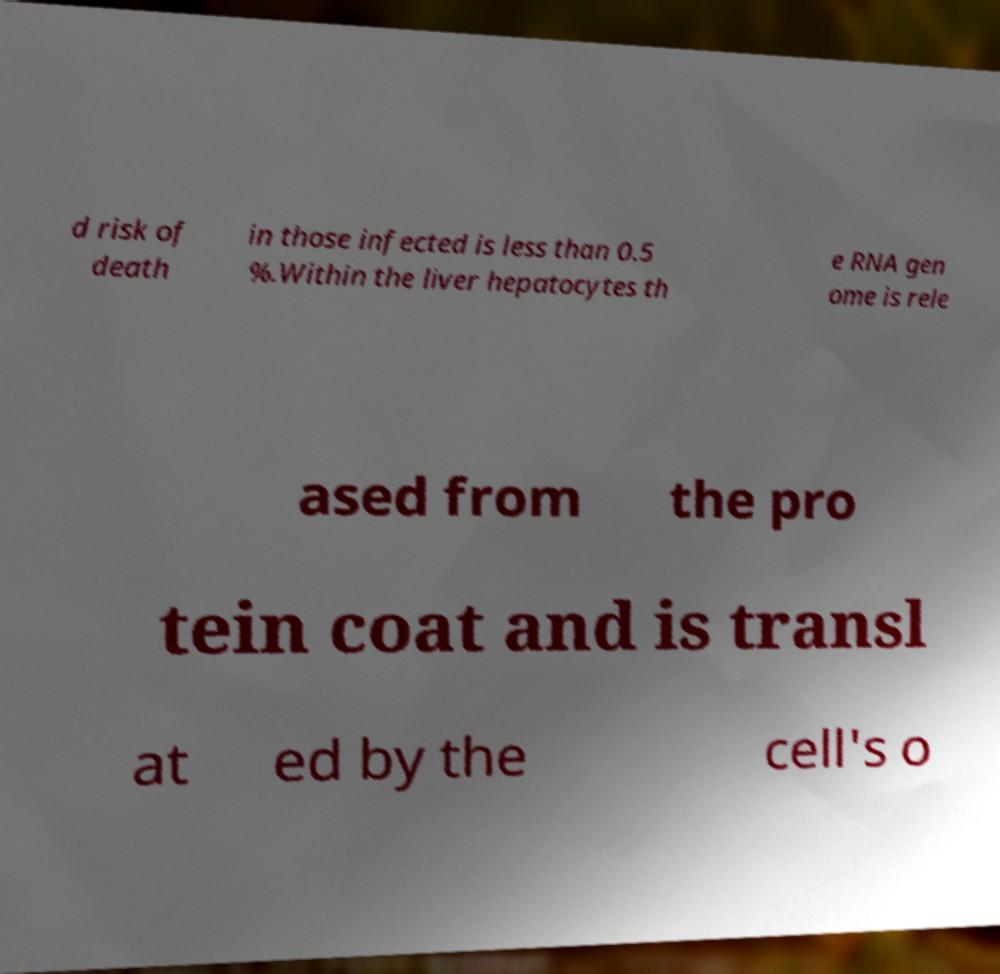What messages or text are displayed in this image? I need them in a readable, typed format. d risk of death in those infected is less than 0.5 %.Within the liver hepatocytes th e RNA gen ome is rele ased from the pro tein coat and is transl at ed by the cell's o 